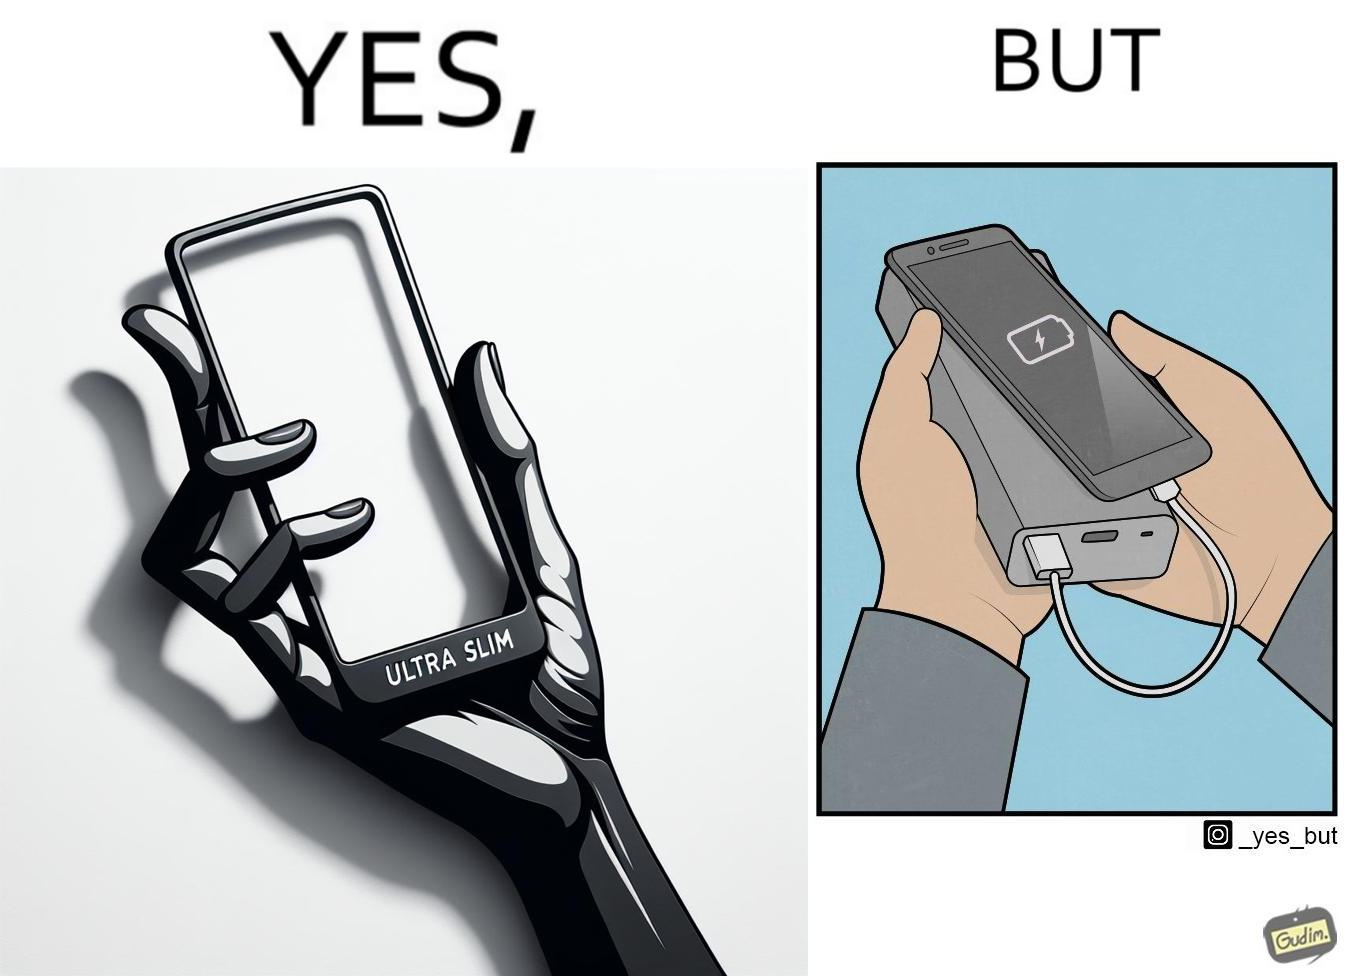Does this image contain satire or humor? Yes, this image is satirical. 